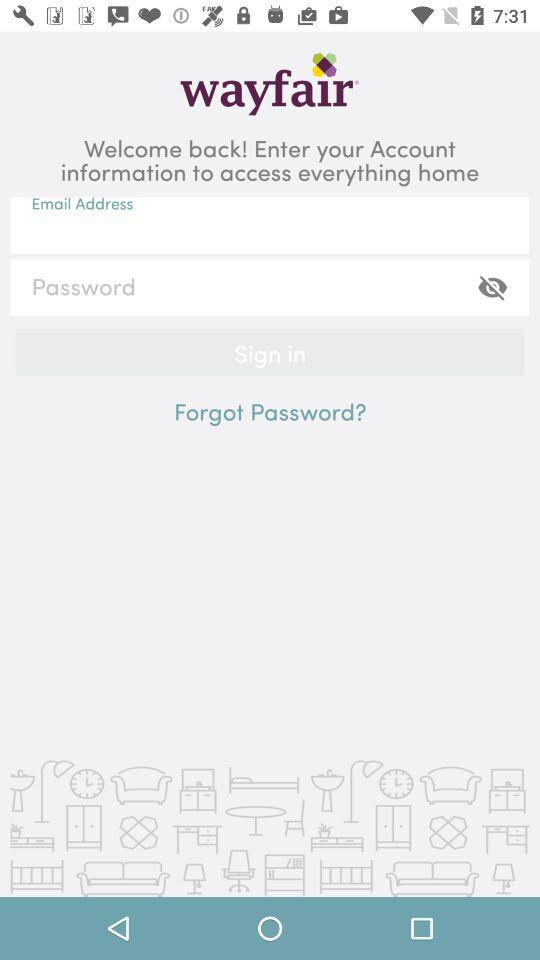How many characters are required to create a password?
When the provided information is insufficient, respond with <no answer>. <no answer> 